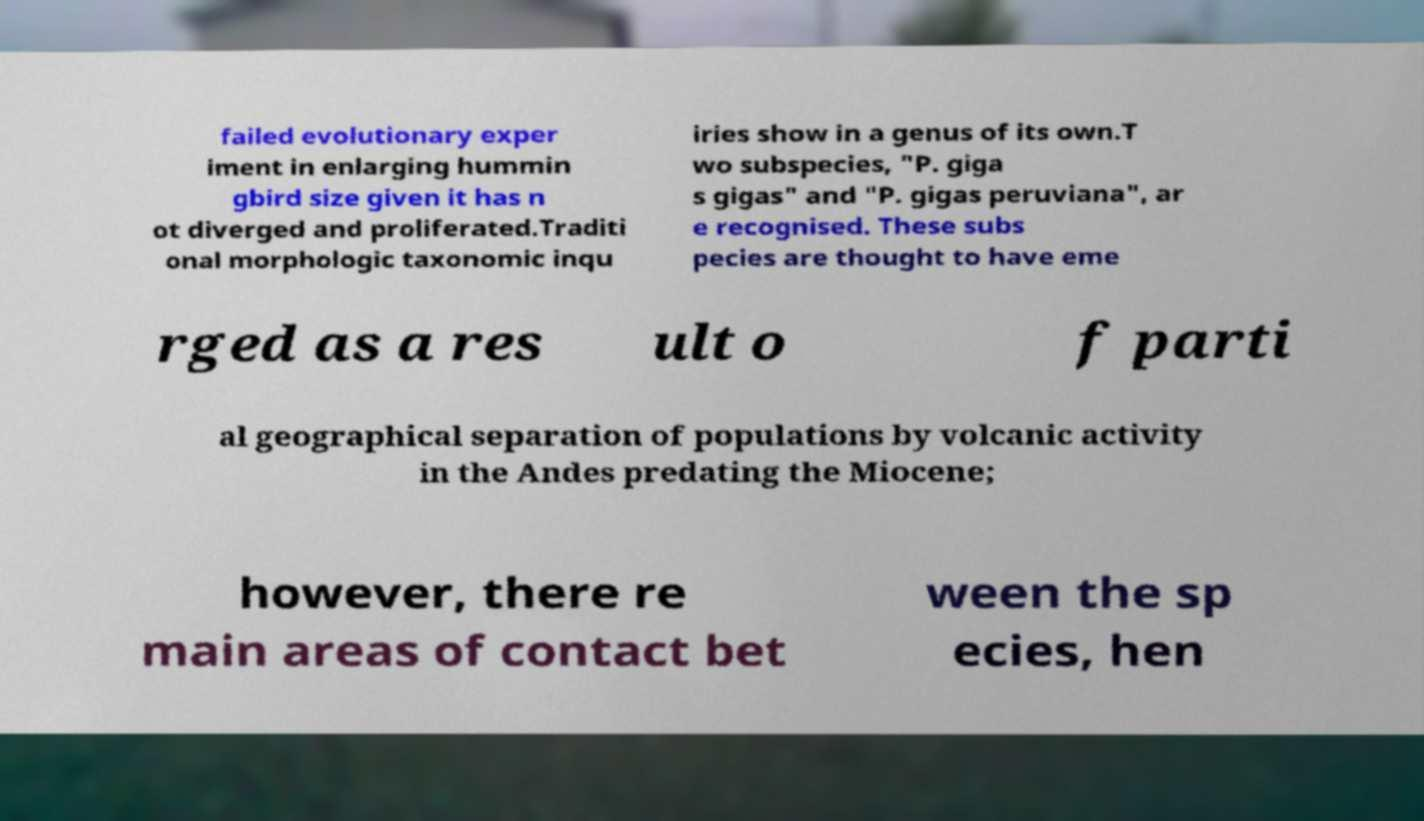Please identify and transcribe the text found in this image. failed evolutionary exper iment in enlarging hummin gbird size given it has n ot diverged and proliferated.Traditi onal morphologic taxonomic inqu iries show in a genus of its own.T wo subspecies, "P. giga s gigas" and "P. gigas peruviana", ar e recognised. These subs pecies are thought to have eme rged as a res ult o f parti al geographical separation of populations by volcanic activity in the Andes predating the Miocene; however, there re main areas of contact bet ween the sp ecies, hen 